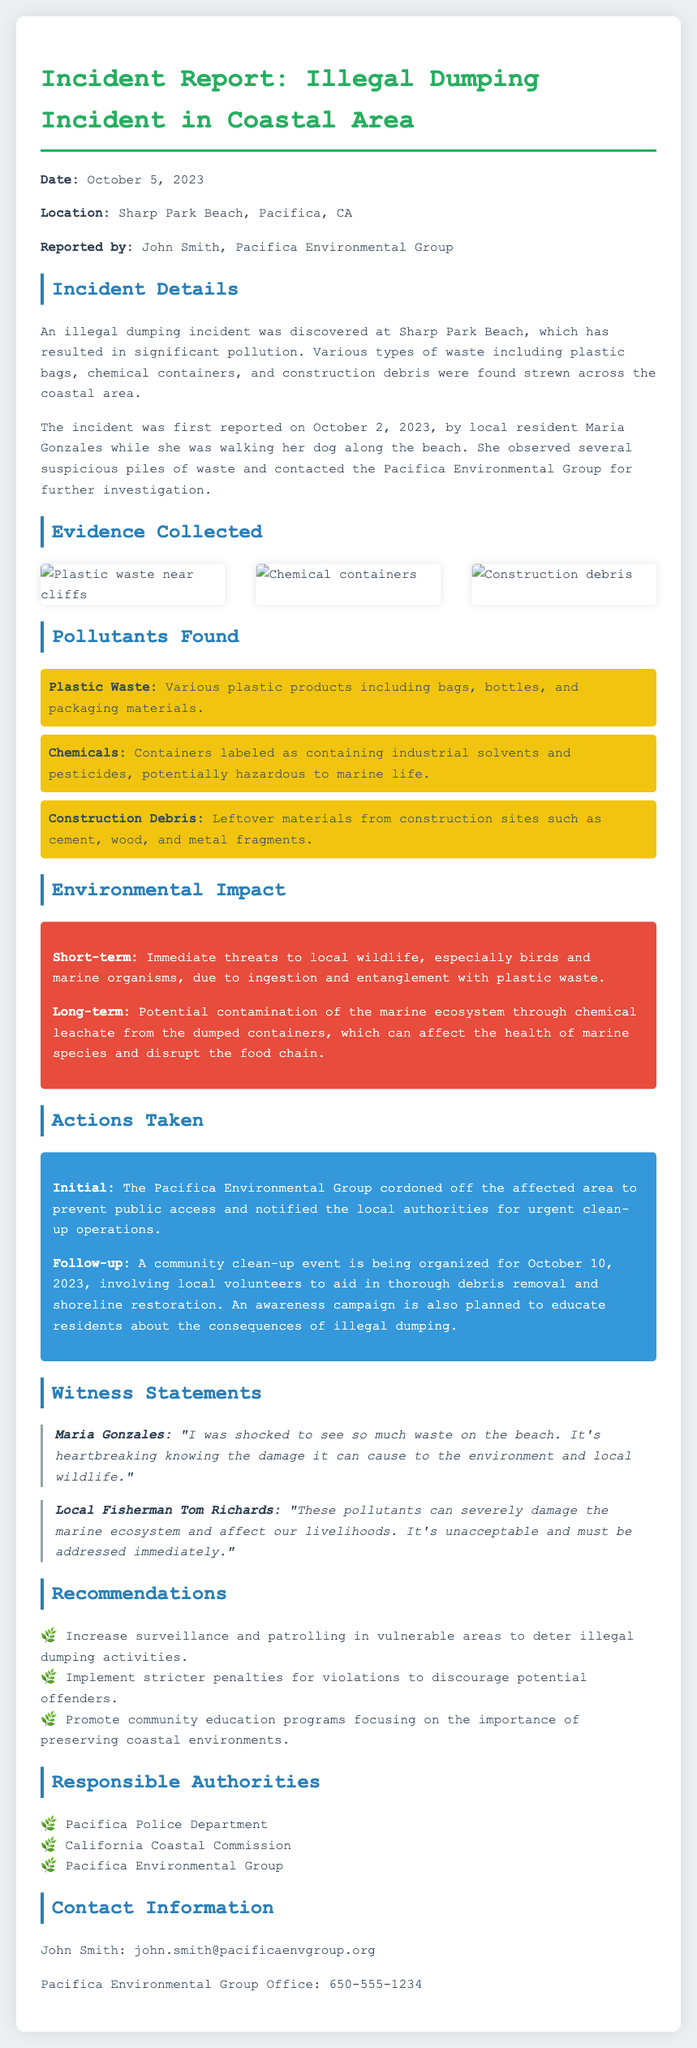What is the date of the incident? The date of the incident is mentioned explicitly in the report, which states October 5, 2023.
Answer: October 5, 2023 What location is reported for the illegal dumping? The location of the incident is specified in the document as Sharp Park Beach, Pacifica, CA.
Answer: Sharp Park Beach, Pacifica, CA Who reported the incident? The report indicates that the incident was reported by John Smith from the Pacifica Environmental Group.
Answer: John Smith What types of pollutants were found? The report lists various pollutants, specifically plastic waste, chemicals, and construction debris.
Answer: Plastic Waste, Chemicals, Construction Debris What was the immediate environmental impact mentioned? The report describes immediate threats to local wildlife as the short-term impact due to pollution.
Answer: Immediate threats to local wildlife What community action is planned in response to the incident? The report mentions a community clean-up event organized for October 10, 2023, to combat the pollution.
Answer: Community clean-up event How was the area secured following the incident? The Pacifica Environmental Group took initial actions to cordon off the affected area to prevent public access.
Answer: Cordoned off the affected area What witness expressed shock at the waste found on the beach? The document includes statements, highlighting that Maria Gonzales expressed shock upon seeing the waste.
Answer: Maria Gonzales What is the purpose of the awareness campaign mentioned in the report? The awareness campaign aims to educate residents about the consequences of illegal dumping as per the document.
Answer: Educate residents about consequences of illegal dumping 